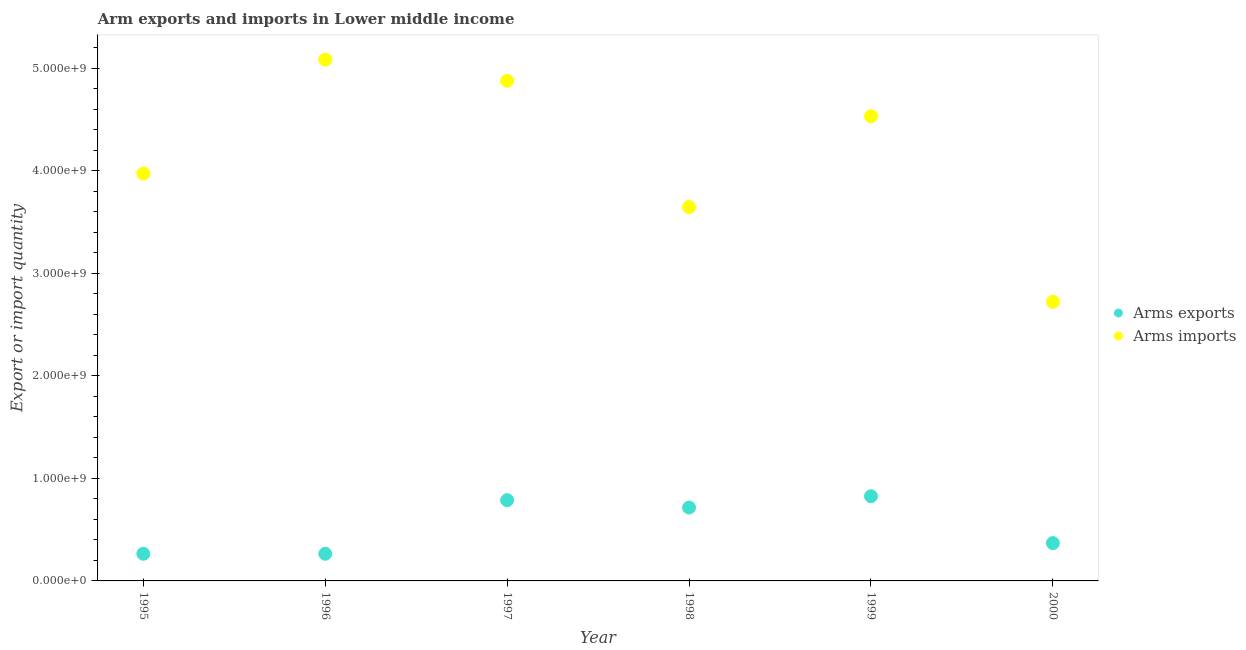Is the number of dotlines equal to the number of legend labels?
Provide a succinct answer. Yes. What is the arms imports in 1998?
Your answer should be compact. 3.65e+09. Across all years, what is the maximum arms imports?
Keep it short and to the point. 5.09e+09. Across all years, what is the minimum arms imports?
Provide a short and direct response. 2.72e+09. In which year was the arms imports maximum?
Your response must be concise. 1996. In which year was the arms imports minimum?
Offer a terse response. 2000. What is the total arms exports in the graph?
Your response must be concise. 3.23e+09. What is the difference between the arms exports in 1997 and that in 1999?
Give a very brief answer. -3.80e+07. What is the difference between the arms imports in 1997 and the arms exports in 1995?
Offer a terse response. 4.61e+09. What is the average arms exports per year?
Your response must be concise. 5.38e+08. In the year 1996, what is the difference between the arms imports and arms exports?
Your answer should be compact. 4.82e+09. In how many years, is the arms imports greater than 4200000000?
Your answer should be very brief. 3. What is the ratio of the arms exports in 1996 to that in 1999?
Your answer should be compact. 0.32. Is the arms imports in 1996 less than that in 2000?
Provide a short and direct response. No. What is the difference between the highest and the second highest arms imports?
Your answer should be compact. 2.07e+08. What is the difference between the highest and the lowest arms imports?
Give a very brief answer. 2.36e+09. Is the sum of the arms exports in 1996 and 2000 greater than the maximum arms imports across all years?
Your answer should be compact. No. Is the arms exports strictly greater than the arms imports over the years?
Give a very brief answer. No. Is the arms imports strictly less than the arms exports over the years?
Your response must be concise. No. What is the difference between two consecutive major ticks on the Y-axis?
Provide a succinct answer. 1.00e+09. Are the values on the major ticks of Y-axis written in scientific E-notation?
Your response must be concise. Yes. Does the graph contain grids?
Make the answer very short. No. Where does the legend appear in the graph?
Give a very brief answer. Center right. How many legend labels are there?
Your answer should be very brief. 2. How are the legend labels stacked?
Offer a terse response. Vertical. What is the title of the graph?
Provide a succinct answer. Arm exports and imports in Lower middle income. Does "Register a property" appear as one of the legend labels in the graph?
Offer a terse response. No. What is the label or title of the Y-axis?
Your response must be concise. Export or import quantity. What is the Export or import quantity of Arms exports in 1995?
Offer a very short reply. 2.65e+08. What is the Export or import quantity of Arms imports in 1995?
Your answer should be very brief. 3.97e+09. What is the Export or import quantity in Arms exports in 1996?
Ensure brevity in your answer.  2.65e+08. What is the Export or import quantity of Arms imports in 1996?
Make the answer very short. 5.09e+09. What is the Export or import quantity of Arms exports in 1997?
Your answer should be very brief. 7.88e+08. What is the Export or import quantity of Arms imports in 1997?
Your answer should be compact. 4.88e+09. What is the Export or import quantity in Arms exports in 1998?
Ensure brevity in your answer.  7.16e+08. What is the Export or import quantity in Arms imports in 1998?
Your response must be concise. 3.65e+09. What is the Export or import quantity in Arms exports in 1999?
Your response must be concise. 8.26e+08. What is the Export or import quantity of Arms imports in 1999?
Your answer should be compact. 4.53e+09. What is the Export or import quantity in Arms exports in 2000?
Your response must be concise. 3.69e+08. What is the Export or import quantity of Arms imports in 2000?
Provide a succinct answer. 2.72e+09. Across all years, what is the maximum Export or import quantity in Arms exports?
Ensure brevity in your answer.  8.26e+08. Across all years, what is the maximum Export or import quantity in Arms imports?
Provide a succinct answer. 5.09e+09. Across all years, what is the minimum Export or import quantity in Arms exports?
Keep it short and to the point. 2.65e+08. Across all years, what is the minimum Export or import quantity of Arms imports?
Ensure brevity in your answer.  2.72e+09. What is the total Export or import quantity of Arms exports in the graph?
Make the answer very short. 3.23e+09. What is the total Export or import quantity in Arms imports in the graph?
Offer a very short reply. 2.48e+1. What is the difference between the Export or import quantity of Arms imports in 1995 and that in 1996?
Ensure brevity in your answer.  -1.11e+09. What is the difference between the Export or import quantity of Arms exports in 1995 and that in 1997?
Keep it short and to the point. -5.23e+08. What is the difference between the Export or import quantity of Arms imports in 1995 and that in 1997?
Give a very brief answer. -9.05e+08. What is the difference between the Export or import quantity in Arms exports in 1995 and that in 1998?
Your answer should be compact. -4.51e+08. What is the difference between the Export or import quantity of Arms imports in 1995 and that in 1998?
Provide a short and direct response. 3.26e+08. What is the difference between the Export or import quantity in Arms exports in 1995 and that in 1999?
Provide a succinct answer. -5.61e+08. What is the difference between the Export or import quantity in Arms imports in 1995 and that in 1999?
Your answer should be very brief. -5.59e+08. What is the difference between the Export or import quantity in Arms exports in 1995 and that in 2000?
Offer a very short reply. -1.04e+08. What is the difference between the Export or import quantity in Arms imports in 1995 and that in 2000?
Your answer should be compact. 1.25e+09. What is the difference between the Export or import quantity in Arms exports in 1996 and that in 1997?
Ensure brevity in your answer.  -5.23e+08. What is the difference between the Export or import quantity of Arms imports in 1996 and that in 1997?
Provide a short and direct response. 2.07e+08. What is the difference between the Export or import quantity of Arms exports in 1996 and that in 1998?
Keep it short and to the point. -4.51e+08. What is the difference between the Export or import quantity of Arms imports in 1996 and that in 1998?
Offer a very short reply. 1.44e+09. What is the difference between the Export or import quantity in Arms exports in 1996 and that in 1999?
Provide a short and direct response. -5.61e+08. What is the difference between the Export or import quantity of Arms imports in 1996 and that in 1999?
Provide a succinct answer. 5.53e+08. What is the difference between the Export or import quantity of Arms exports in 1996 and that in 2000?
Make the answer very short. -1.04e+08. What is the difference between the Export or import quantity in Arms imports in 1996 and that in 2000?
Make the answer very short. 2.36e+09. What is the difference between the Export or import quantity in Arms exports in 1997 and that in 1998?
Provide a short and direct response. 7.20e+07. What is the difference between the Export or import quantity of Arms imports in 1997 and that in 1998?
Your answer should be very brief. 1.23e+09. What is the difference between the Export or import quantity in Arms exports in 1997 and that in 1999?
Your answer should be compact. -3.80e+07. What is the difference between the Export or import quantity of Arms imports in 1997 and that in 1999?
Your answer should be compact. 3.46e+08. What is the difference between the Export or import quantity of Arms exports in 1997 and that in 2000?
Your answer should be compact. 4.19e+08. What is the difference between the Export or import quantity in Arms imports in 1997 and that in 2000?
Give a very brief answer. 2.16e+09. What is the difference between the Export or import quantity of Arms exports in 1998 and that in 1999?
Provide a short and direct response. -1.10e+08. What is the difference between the Export or import quantity in Arms imports in 1998 and that in 1999?
Your answer should be compact. -8.85e+08. What is the difference between the Export or import quantity in Arms exports in 1998 and that in 2000?
Your response must be concise. 3.47e+08. What is the difference between the Export or import quantity in Arms imports in 1998 and that in 2000?
Provide a short and direct response. 9.25e+08. What is the difference between the Export or import quantity in Arms exports in 1999 and that in 2000?
Ensure brevity in your answer.  4.57e+08. What is the difference between the Export or import quantity of Arms imports in 1999 and that in 2000?
Your answer should be compact. 1.81e+09. What is the difference between the Export or import quantity in Arms exports in 1995 and the Export or import quantity in Arms imports in 1996?
Offer a very short reply. -4.82e+09. What is the difference between the Export or import quantity of Arms exports in 1995 and the Export or import quantity of Arms imports in 1997?
Offer a terse response. -4.61e+09. What is the difference between the Export or import quantity of Arms exports in 1995 and the Export or import quantity of Arms imports in 1998?
Keep it short and to the point. -3.38e+09. What is the difference between the Export or import quantity in Arms exports in 1995 and the Export or import quantity in Arms imports in 1999?
Your response must be concise. -4.27e+09. What is the difference between the Export or import quantity of Arms exports in 1995 and the Export or import quantity of Arms imports in 2000?
Offer a very short reply. -2.46e+09. What is the difference between the Export or import quantity in Arms exports in 1996 and the Export or import quantity in Arms imports in 1997?
Offer a very short reply. -4.61e+09. What is the difference between the Export or import quantity of Arms exports in 1996 and the Export or import quantity of Arms imports in 1998?
Offer a terse response. -3.38e+09. What is the difference between the Export or import quantity of Arms exports in 1996 and the Export or import quantity of Arms imports in 1999?
Give a very brief answer. -4.27e+09. What is the difference between the Export or import quantity in Arms exports in 1996 and the Export or import quantity in Arms imports in 2000?
Provide a short and direct response. -2.46e+09. What is the difference between the Export or import quantity of Arms exports in 1997 and the Export or import quantity of Arms imports in 1998?
Offer a very short reply. -2.86e+09. What is the difference between the Export or import quantity of Arms exports in 1997 and the Export or import quantity of Arms imports in 1999?
Make the answer very short. -3.74e+09. What is the difference between the Export or import quantity of Arms exports in 1997 and the Export or import quantity of Arms imports in 2000?
Keep it short and to the point. -1.94e+09. What is the difference between the Export or import quantity in Arms exports in 1998 and the Export or import quantity in Arms imports in 1999?
Make the answer very short. -3.82e+09. What is the difference between the Export or import quantity in Arms exports in 1998 and the Export or import quantity in Arms imports in 2000?
Provide a succinct answer. -2.01e+09. What is the difference between the Export or import quantity of Arms exports in 1999 and the Export or import quantity of Arms imports in 2000?
Give a very brief answer. -1.90e+09. What is the average Export or import quantity of Arms exports per year?
Your response must be concise. 5.38e+08. What is the average Export or import quantity of Arms imports per year?
Keep it short and to the point. 4.14e+09. In the year 1995, what is the difference between the Export or import quantity of Arms exports and Export or import quantity of Arms imports?
Offer a terse response. -3.71e+09. In the year 1996, what is the difference between the Export or import quantity in Arms exports and Export or import quantity in Arms imports?
Make the answer very short. -4.82e+09. In the year 1997, what is the difference between the Export or import quantity of Arms exports and Export or import quantity of Arms imports?
Ensure brevity in your answer.  -4.09e+09. In the year 1998, what is the difference between the Export or import quantity of Arms exports and Export or import quantity of Arms imports?
Your answer should be compact. -2.93e+09. In the year 1999, what is the difference between the Export or import quantity in Arms exports and Export or import quantity in Arms imports?
Make the answer very short. -3.71e+09. In the year 2000, what is the difference between the Export or import quantity in Arms exports and Export or import quantity in Arms imports?
Your answer should be very brief. -2.35e+09. What is the ratio of the Export or import quantity of Arms imports in 1995 to that in 1996?
Give a very brief answer. 0.78. What is the ratio of the Export or import quantity in Arms exports in 1995 to that in 1997?
Make the answer very short. 0.34. What is the ratio of the Export or import quantity of Arms imports in 1995 to that in 1997?
Your answer should be very brief. 0.81. What is the ratio of the Export or import quantity in Arms exports in 1995 to that in 1998?
Your answer should be very brief. 0.37. What is the ratio of the Export or import quantity of Arms imports in 1995 to that in 1998?
Offer a very short reply. 1.09. What is the ratio of the Export or import quantity of Arms exports in 1995 to that in 1999?
Give a very brief answer. 0.32. What is the ratio of the Export or import quantity in Arms imports in 1995 to that in 1999?
Offer a very short reply. 0.88. What is the ratio of the Export or import quantity in Arms exports in 1995 to that in 2000?
Give a very brief answer. 0.72. What is the ratio of the Export or import quantity of Arms imports in 1995 to that in 2000?
Keep it short and to the point. 1.46. What is the ratio of the Export or import quantity in Arms exports in 1996 to that in 1997?
Ensure brevity in your answer.  0.34. What is the ratio of the Export or import quantity of Arms imports in 1996 to that in 1997?
Give a very brief answer. 1.04. What is the ratio of the Export or import quantity of Arms exports in 1996 to that in 1998?
Your answer should be very brief. 0.37. What is the ratio of the Export or import quantity of Arms imports in 1996 to that in 1998?
Ensure brevity in your answer.  1.39. What is the ratio of the Export or import quantity of Arms exports in 1996 to that in 1999?
Provide a succinct answer. 0.32. What is the ratio of the Export or import quantity of Arms imports in 1996 to that in 1999?
Your answer should be very brief. 1.12. What is the ratio of the Export or import quantity of Arms exports in 1996 to that in 2000?
Give a very brief answer. 0.72. What is the ratio of the Export or import quantity of Arms imports in 1996 to that in 2000?
Offer a terse response. 1.87. What is the ratio of the Export or import quantity of Arms exports in 1997 to that in 1998?
Give a very brief answer. 1.1. What is the ratio of the Export or import quantity in Arms imports in 1997 to that in 1998?
Make the answer very short. 1.34. What is the ratio of the Export or import quantity of Arms exports in 1997 to that in 1999?
Ensure brevity in your answer.  0.95. What is the ratio of the Export or import quantity of Arms imports in 1997 to that in 1999?
Make the answer very short. 1.08. What is the ratio of the Export or import quantity in Arms exports in 1997 to that in 2000?
Your answer should be very brief. 2.14. What is the ratio of the Export or import quantity in Arms imports in 1997 to that in 2000?
Offer a terse response. 1.79. What is the ratio of the Export or import quantity of Arms exports in 1998 to that in 1999?
Give a very brief answer. 0.87. What is the ratio of the Export or import quantity of Arms imports in 1998 to that in 1999?
Keep it short and to the point. 0.8. What is the ratio of the Export or import quantity in Arms exports in 1998 to that in 2000?
Provide a short and direct response. 1.94. What is the ratio of the Export or import quantity of Arms imports in 1998 to that in 2000?
Ensure brevity in your answer.  1.34. What is the ratio of the Export or import quantity of Arms exports in 1999 to that in 2000?
Your answer should be very brief. 2.24. What is the ratio of the Export or import quantity of Arms imports in 1999 to that in 2000?
Ensure brevity in your answer.  1.66. What is the difference between the highest and the second highest Export or import quantity of Arms exports?
Your answer should be very brief. 3.80e+07. What is the difference between the highest and the second highest Export or import quantity in Arms imports?
Your answer should be compact. 2.07e+08. What is the difference between the highest and the lowest Export or import quantity in Arms exports?
Make the answer very short. 5.61e+08. What is the difference between the highest and the lowest Export or import quantity in Arms imports?
Provide a succinct answer. 2.36e+09. 